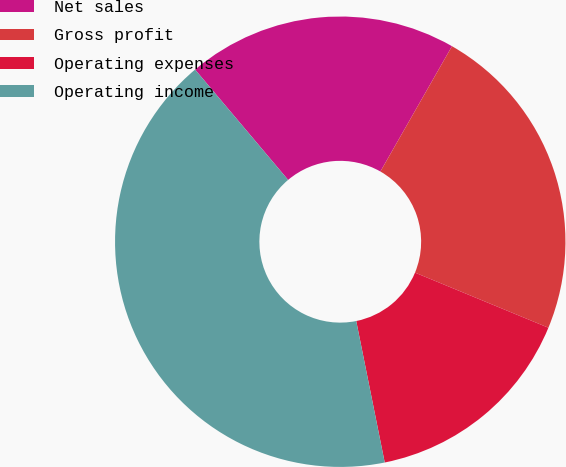<chart> <loc_0><loc_0><loc_500><loc_500><pie_chart><fcel>Net sales<fcel>Gross profit<fcel>Operating expenses<fcel>Operating income<nl><fcel>19.41%<fcel>22.97%<fcel>15.6%<fcel>42.01%<nl></chart> 